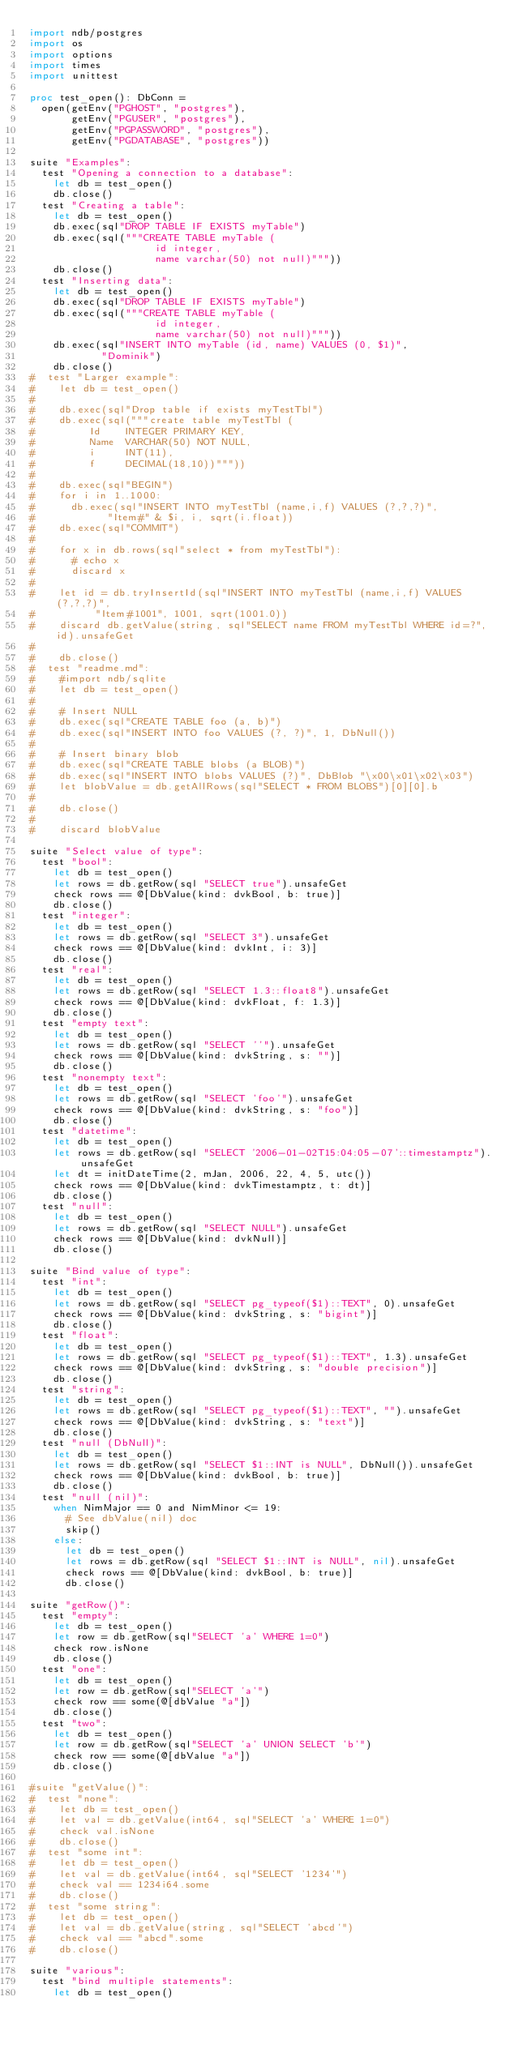Convert code to text. <code><loc_0><loc_0><loc_500><loc_500><_Nim_>import ndb/postgres
import os
import options
import times
import unittest

proc test_open(): DbConn =
  open(getEnv("PGHOST", "postgres"),
       getEnv("PGUSER", "postgres"),
       getEnv("PGPASSWORD", "postgres"),
       getEnv("PGDATABASE", "postgres"))

suite "Examples":
  test "Opening a connection to a database":
    let db = test_open()
    db.close()
  test "Creating a table":
    let db = test_open()
    db.exec(sql"DROP TABLE IF EXISTS myTable")
    db.exec(sql("""CREATE TABLE myTable (
                     id integer,
                     name varchar(50) not null)"""))
    db.close()
  test "Inserting data":
    let db = test_open()
    db.exec(sql"DROP TABLE IF EXISTS myTable")
    db.exec(sql("""CREATE TABLE myTable (
                     id integer,
                     name varchar(50) not null)"""))
    db.exec(sql"INSERT INTO myTable (id, name) VALUES (0, $1)",
            "Dominik")
    db.close()
#  test "Larger example":
#    let db = test_open()
#
#    db.exec(sql"Drop table if exists myTestTbl")
#    db.exec(sql("""create table myTestTbl (
#         Id    INTEGER PRIMARY KEY,
#         Name  VARCHAR(50) NOT NULL,
#         i     INT(11),
#         f     DECIMAL(18,10))"""))
#
#    db.exec(sql"BEGIN")
#    for i in 1..1000:
#      db.exec(sql"INSERT INTO myTestTbl (name,i,f) VALUES (?,?,?)",
#            "Item#" & $i, i, sqrt(i.float))
#    db.exec(sql"COMMIT")
#
#    for x in db.rows(sql"select * from myTestTbl"):
#      # echo x
#      discard x
#
#    let id = db.tryInsertId(sql"INSERT INTO myTestTbl (name,i,f) VALUES (?,?,?)",
#          "Item#1001", 1001, sqrt(1001.0))
#    discard db.getValue(string, sql"SELECT name FROM myTestTbl WHERE id=?", id).unsafeGet
#
#    db.close()
#  test "readme.md":
#    #import ndb/sqlite
#    let db = test_open()
#
#    # Insert NULL
#    db.exec(sql"CREATE TABLE foo (a, b)")
#    db.exec(sql"INSERT INTO foo VALUES (?, ?)", 1, DbNull())
#
#    # Insert binary blob
#    db.exec(sql"CREATE TABLE blobs (a BLOB)")
#    db.exec(sql"INSERT INTO blobs VALUES (?)", DbBlob "\x00\x01\x02\x03")
#    let blobValue = db.getAllRows(sql"SELECT * FROM BLOBS")[0][0].b
#
#    db.close()
#
#    discard blobValue

suite "Select value of type":
  test "bool":
    let db = test_open()
    let rows = db.getRow(sql "SELECT true").unsafeGet
    check rows == @[DbValue(kind: dvkBool, b: true)]
    db.close()
  test "integer":
    let db = test_open()
    let rows = db.getRow(sql "SELECT 3").unsafeGet
    check rows == @[DbValue(kind: dvkInt, i: 3)]
    db.close()
  test "real":
    let db = test_open()
    let rows = db.getRow(sql "SELECT 1.3::float8").unsafeGet
    check rows == @[DbValue(kind: dvkFloat, f: 1.3)]
    db.close()
  test "empty text":
    let db = test_open()
    let rows = db.getRow(sql "SELECT ''").unsafeGet
    check rows == @[DbValue(kind: dvkString, s: "")]
    db.close()
  test "nonempty text":
    let db = test_open()
    let rows = db.getRow(sql "SELECT 'foo'").unsafeGet
    check rows == @[DbValue(kind: dvkString, s: "foo")]
    db.close()
  test "datetime":
    let db = test_open()
    let rows = db.getRow(sql "SELECT '2006-01-02T15:04:05-07'::timestamptz").unsafeGet
    let dt = initDateTime(2, mJan, 2006, 22, 4, 5, utc())
    check rows == @[DbValue(kind: dvkTimestamptz, t: dt)]
    db.close()
  test "null":
    let db = test_open()
    let rows = db.getRow(sql "SELECT NULL").unsafeGet
    check rows == @[DbValue(kind: dvkNull)]
    db.close()

suite "Bind value of type":
  test "int":
    let db = test_open()
    let rows = db.getRow(sql "SELECT pg_typeof($1)::TEXT", 0).unsafeGet
    check rows == @[DbValue(kind: dvkString, s: "bigint")]
    db.close()
  test "float":
    let db = test_open()
    let rows = db.getRow(sql "SELECT pg_typeof($1)::TEXT", 1.3).unsafeGet
    check rows == @[DbValue(kind: dvkString, s: "double precision")]
    db.close()
  test "string":
    let db = test_open()
    let rows = db.getRow(sql "SELECT pg_typeof($1)::TEXT", "").unsafeGet
    check rows == @[DbValue(kind: dvkString, s: "text")]
    db.close()
  test "null (DbNull)":
    let db = test_open()
    let rows = db.getRow(sql "SELECT $1::INT is NULL", DbNull()).unsafeGet
    check rows == @[DbValue(kind: dvkBool, b: true)]
    db.close()
  test "null (nil)":
    when NimMajor == 0 and NimMinor <= 19:
      # See dbValue(nil) doc
      skip()
    else:
      let db = test_open()
      let rows = db.getRow(sql "SELECT $1::INT is NULL", nil).unsafeGet
      check rows == @[DbValue(kind: dvkBool, b: true)]
      db.close()

suite "getRow()":
  test "empty":
    let db = test_open()
    let row = db.getRow(sql"SELECT 'a' WHERE 1=0")
    check row.isNone
    db.close()
  test "one":
    let db = test_open()
    let row = db.getRow(sql"SELECT 'a'")
    check row == some(@[dbValue "a"])
    db.close()
  test "two":
    let db = test_open()
    let row = db.getRow(sql"SELECT 'a' UNION SELECT 'b'")
    check row == some(@[dbValue "a"])
    db.close()

#suite "getValue()":
#  test "none":
#    let db = test_open()
#    let val = db.getValue(int64, sql"SELECT 'a' WHERE 1=0")
#    check val.isNone
#    db.close()
#  test "some int":
#    let db = test_open()
#    let val = db.getValue(int64, sql"SELECT '1234'")
#    check val == 1234i64.some
#    db.close()
#  test "some string":
#    let db = test_open()
#    let val = db.getValue(string, sql"SELECT 'abcd'")
#    check val == "abcd".some
#    db.close()

suite "various":
  test "bind multiple statements":
    let db = test_open()</code> 